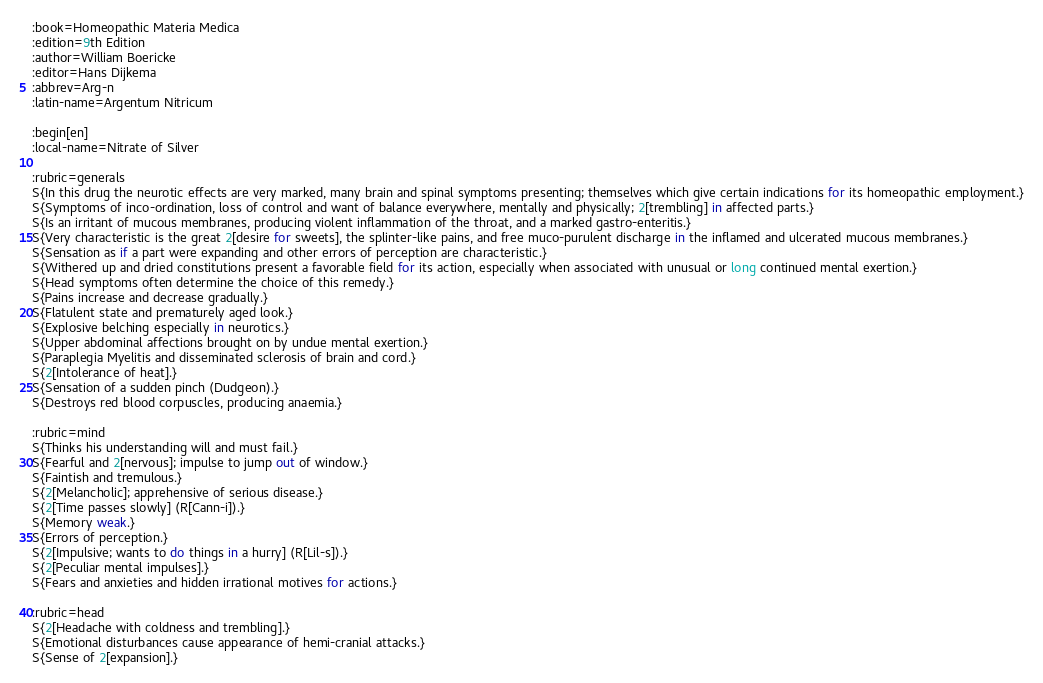Convert code to text. <code><loc_0><loc_0><loc_500><loc_500><_ObjectiveC_>:book=Homeopathic Materia Medica
:edition=9th Edition
:author=William Boericke
:editor=Hans Dijkema
:abbrev=Arg-n
:latin-name=Argentum Nitricum

:begin[en]
:local-name=Nitrate of Silver

:rubric=generals
S{In this drug the neurotic effects are very marked, many brain and spinal symptoms presenting; themselves which give certain indications for its homeopathic employment.}
S{Symptoms of inco-ordination, loss of control and want of balance everywhere, mentally and physically; 2[trembling] in affected parts.}
S{Is an irritant of mucous membranes, producing violent inflammation of the throat, and a marked gastro-enteritis.}
S{Very characteristic is the great 2[desire for sweets], the splinter-like pains, and free muco-purulent discharge in the inflamed and ulcerated mucous membranes.}
S{Sensation as if a part were expanding and other errors of perception are characteristic.}
S{Withered up and dried constitutions present a favorable field for its action, especially when associated with unusual or long continued mental exertion.}
S{Head symptoms often determine the choice of this remedy.}
S{Pains increase and decrease gradually.}
S{Flatulent state and prematurely aged look.}
S{Explosive belching especially in neurotics.}
S{Upper abdominal affections brought on by undue mental exertion.}
S{Paraplegia Myelitis and disseminated sclerosis of brain and cord.}
S{2[Intolerance of heat].}
S{Sensation of a sudden pinch (Dudgeon).}
S{Destroys red blood corpuscles, producing anaemia.}

:rubric=mind
S{Thinks his understanding will and must fail.}
S{Fearful and 2[nervous]; impulse to jump out of window.}
S{Faintish and tremulous.}
S{2[Melancholic]; apprehensive of serious disease.}
S{2[Time passes slowly] (R[Cann-i]).}
S{Memory weak.}
S{Errors of perception.}
S{2[Impulsive; wants to do things in a hurry] (R[Lil-s]).}
S{2[Peculiar mental impulses].}
S{Fears and anxieties and hidden irrational motives for actions.}

:rubric=head
S{2[Headache with coldness and trembling].}
S{Emotional disturbances cause appearance of hemi-cranial attacks.}
S{Sense of 2[expansion].}</code> 